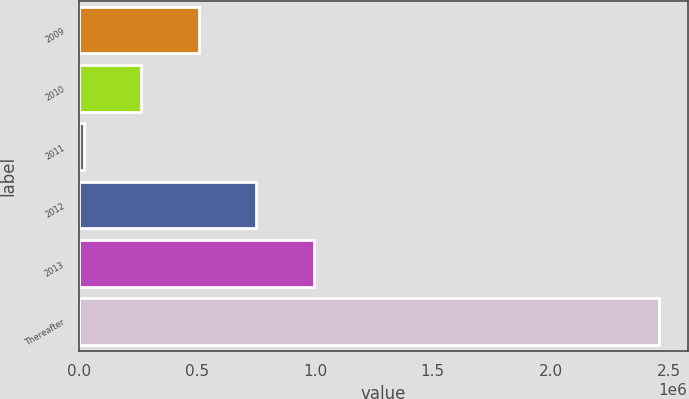<chart> <loc_0><loc_0><loc_500><loc_500><bar_chart><fcel>2009<fcel>2010<fcel>2011<fcel>2012<fcel>2013<fcel>Thereafter<nl><fcel>507018<fcel>263093<fcel>19168<fcel>750943<fcel>994868<fcel>2.45842e+06<nl></chart> 